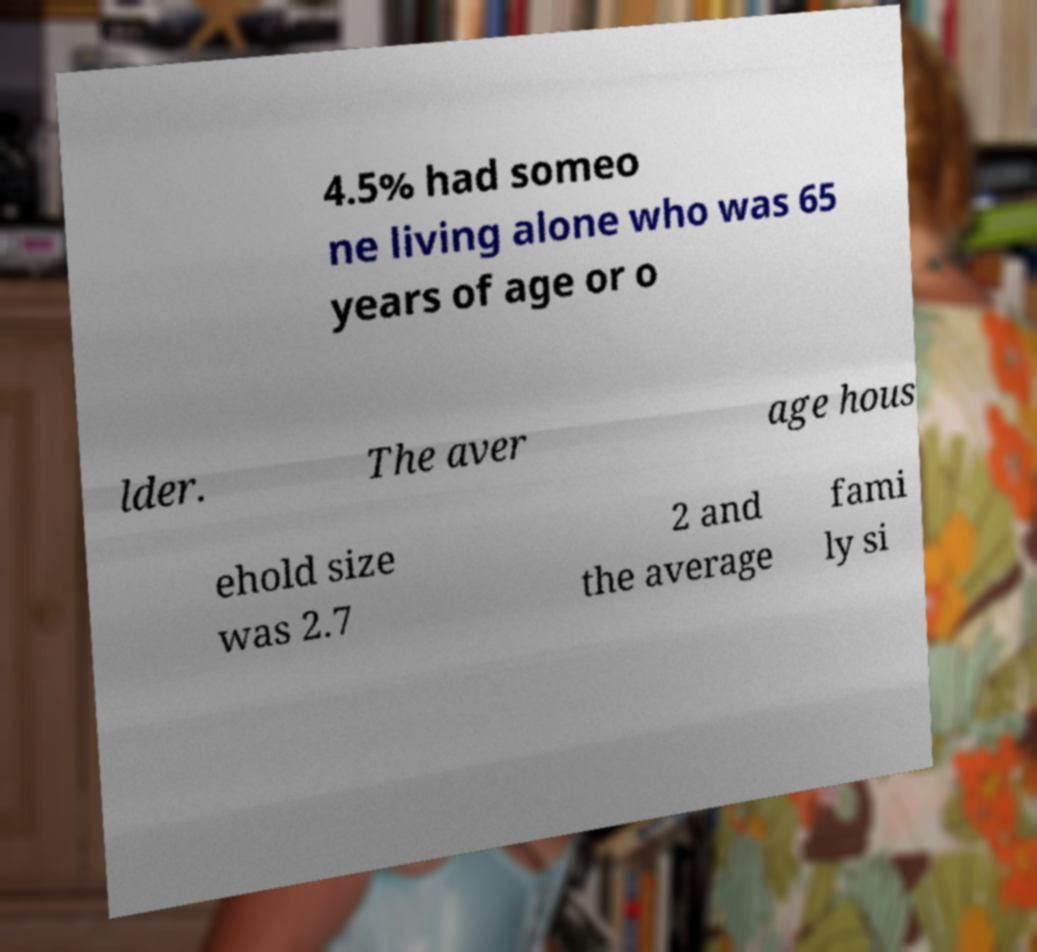I need the written content from this picture converted into text. Can you do that? 4.5% had someo ne living alone who was 65 years of age or o lder. The aver age hous ehold size was 2.7 2 and the average fami ly si 